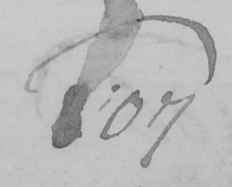Transcribe the text shown in this historical manuscript line. 107 